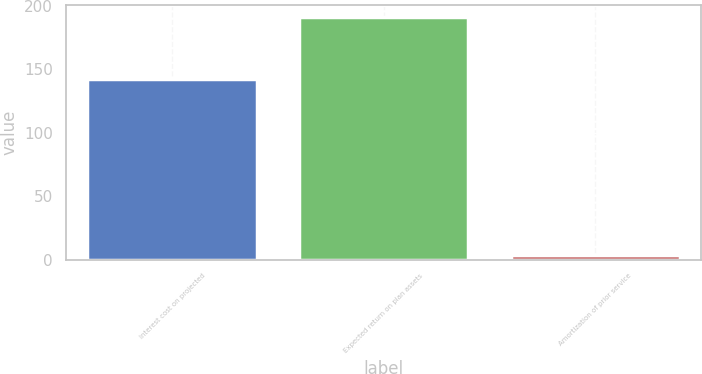<chart> <loc_0><loc_0><loc_500><loc_500><bar_chart><fcel>Interest cost on projected<fcel>Expected return on plan assets<fcel>Amortization of prior service<nl><fcel>142<fcel>191<fcel>4<nl></chart> 